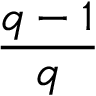Convert formula to latex. <formula><loc_0><loc_0><loc_500><loc_500>\frac { q - 1 } { q }</formula> 